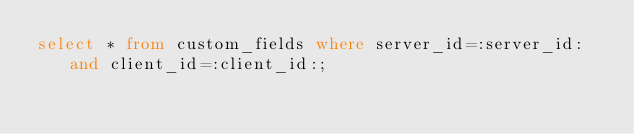Convert code to text. <code><loc_0><loc_0><loc_500><loc_500><_SQL_>select * from custom_fields where server_id=:server_id: and client_id=:client_id:;</code> 